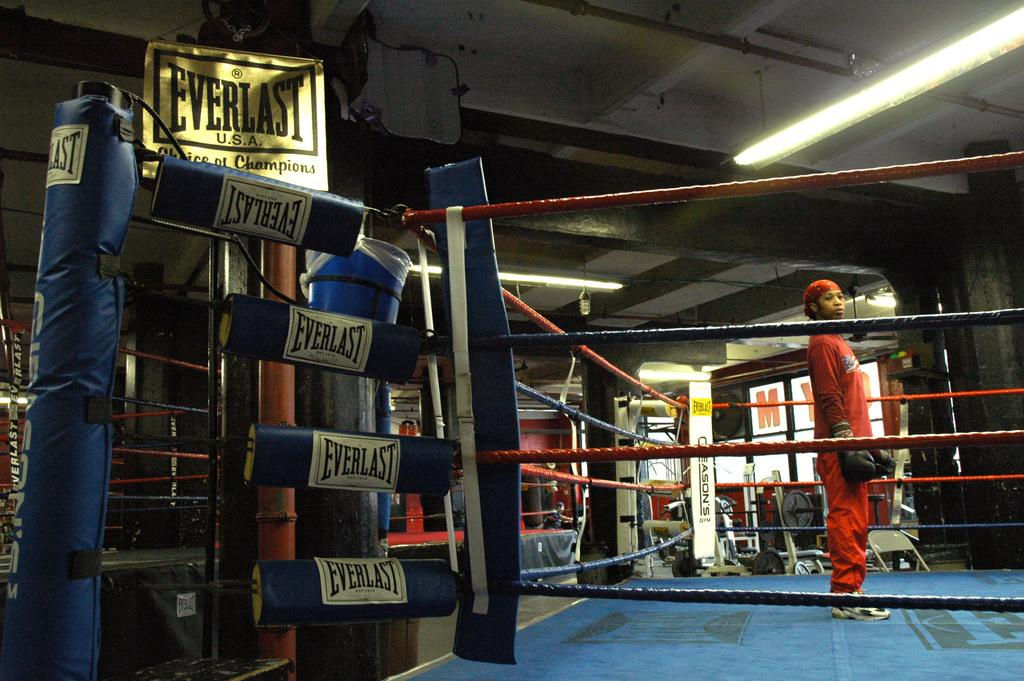<image>
Give a short and clear explanation of the subsequent image. A boxer is standing in a ring with Everlast signs on it. 